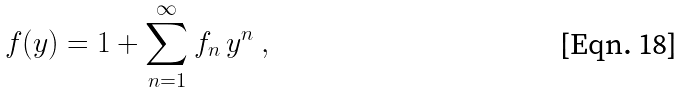Convert formula to latex. <formula><loc_0><loc_0><loc_500><loc_500>f ( y ) = 1 + \sum _ { n = 1 } ^ { \infty } f _ { n } \, y ^ { n } \ ,</formula> 